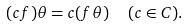Convert formula to latex. <formula><loc_0><loc_0><loc_500><loc_500>( c f ) \theta = c ( f \theta ) \ \ ( c \in C ) .</formula> 